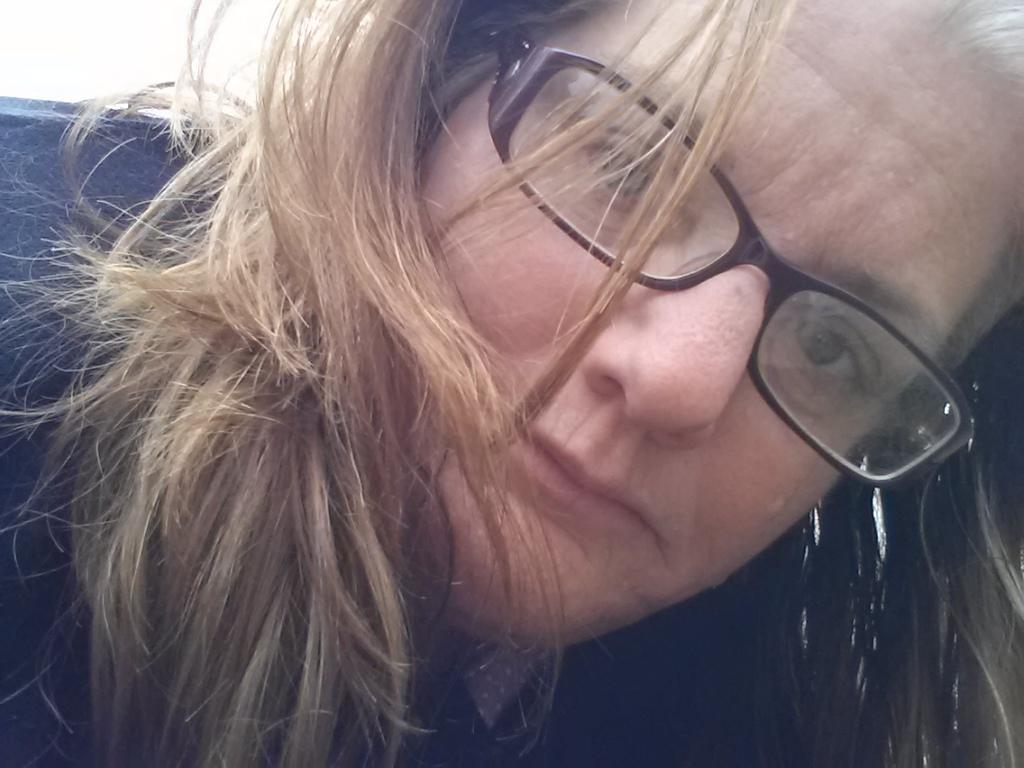What is present in the image? There is a person in the image. Can you describe the person's appearance? The person is wearing spectacles. What type of bear can be seen interacting with the person in the image? There is no bear present in the image; it only features a person wearing spectacles. What hobbies does the person in the image enjoy? The provided facts do not give any information about the person's hobbies, so we cannot determine their interests from the image. 